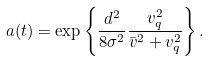Convert formula to latex. <formula><loc_0><loc_0><loc_500><loc_500>a ( t ) = \exp \left \{ \frac { d ^ { 2 } } { 8 \sigma ^ { 2 } } \frac { v ^ { 2 } _ { q } } { \bar { v } ^ { 2 } + v ^ { 2 } _ { q } } \right \} .</formula> 